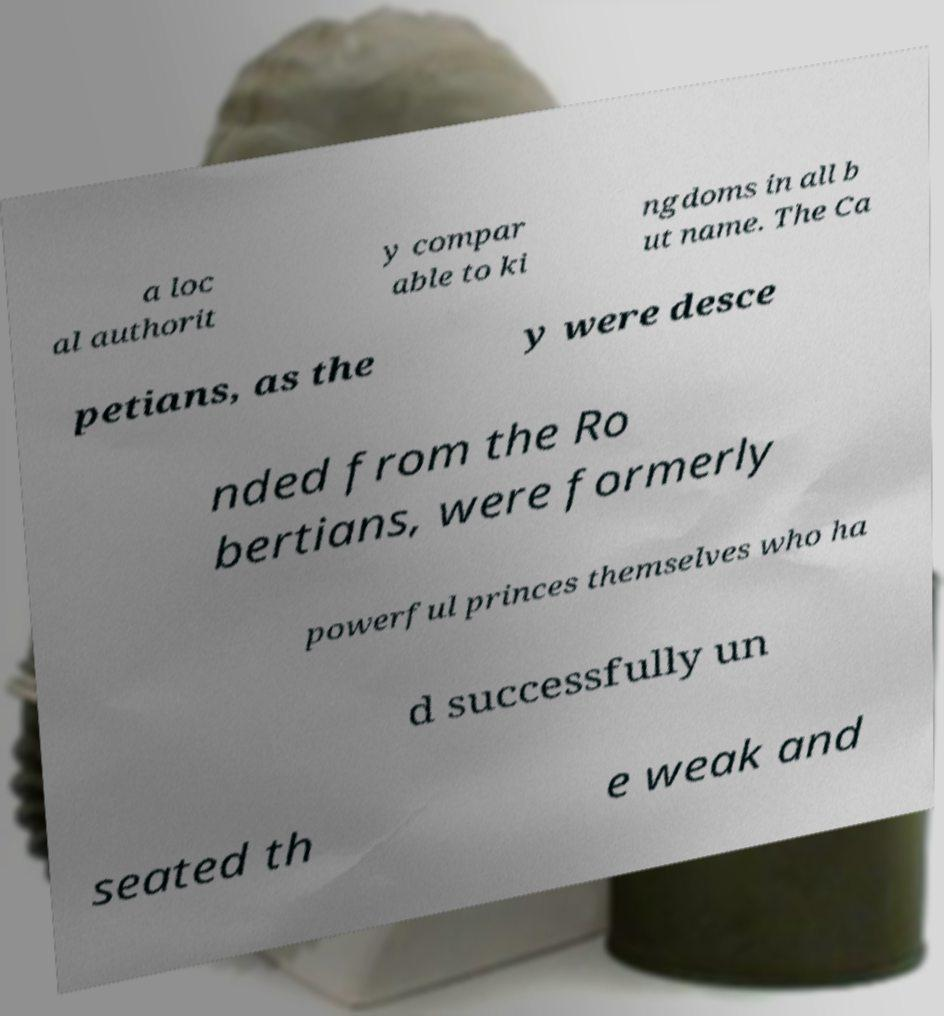Can you read and provide the text displayed in the image?This photo seems to have some interesting text. Can you extract and type it out for me? a loc al authorit y compar able to ki ngdoms in all b ut name. The Ca petians, as the y were desce nded from the Ro bertians, were formerly powerful princes themselves who ha d successfully un seated th e weak and 